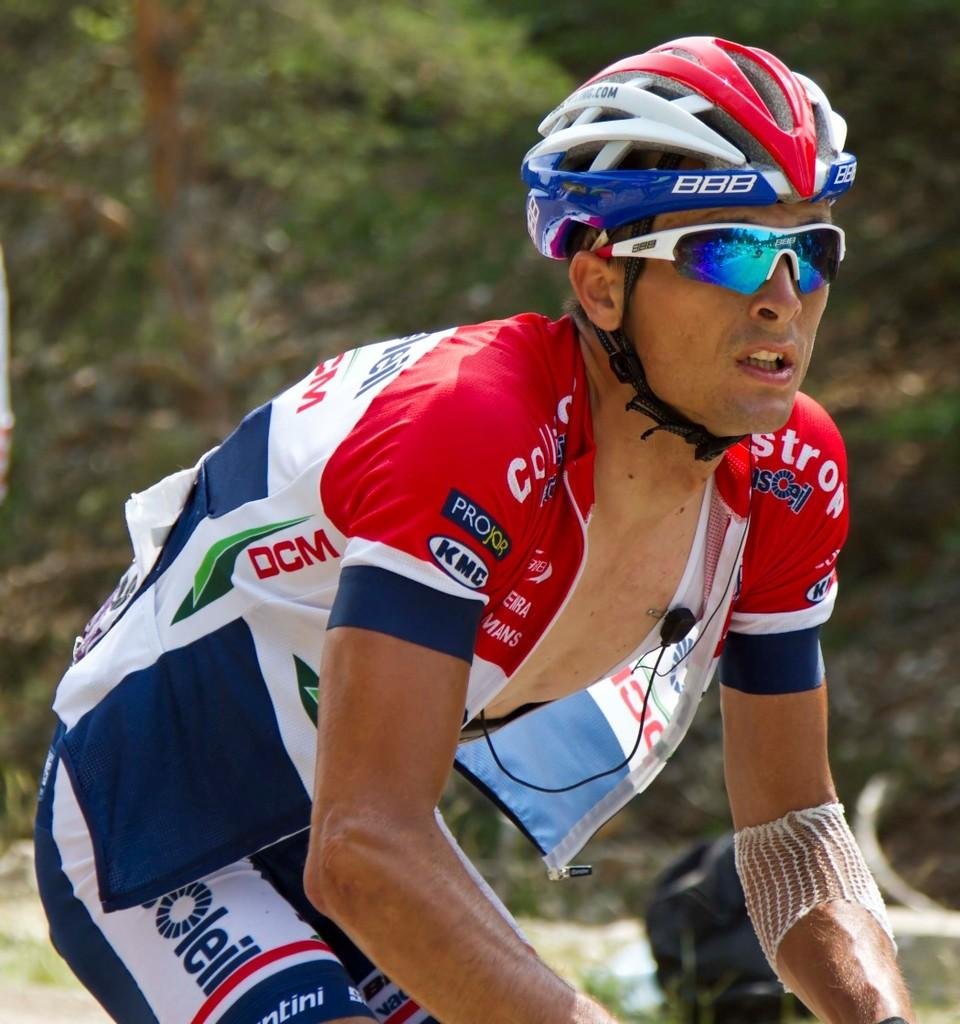Who is present in the image? There is a man in the image. What protective gear is the man wearing? The man is wearing goggles and a helmet. What type of natural environment can be seen in the image? There are trees visible in the image. What month is depicted in the image? The image does not depict a specific month; it only shows a man wearing goggles and a helmet, along with trees in the background. Is there a mailbox present in the image? No, there is no mailbox visible in the image. 